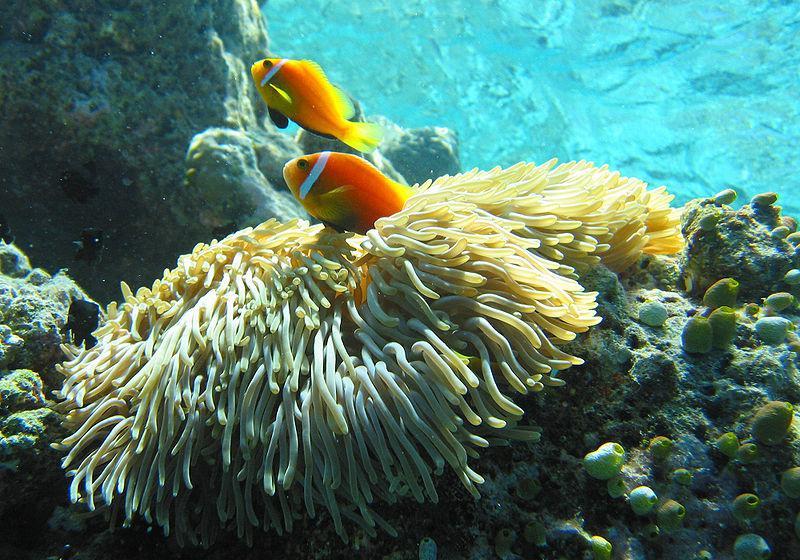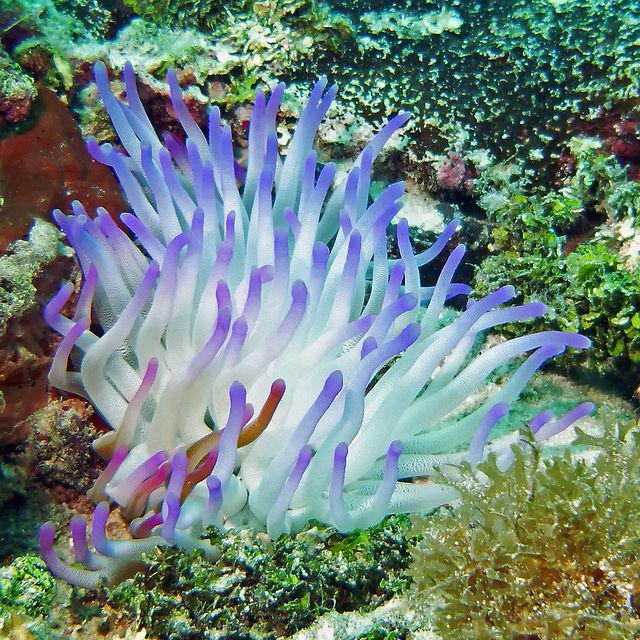The first image is the image on the left, the second image is the image on the right. Given the left and right images, does the statement "No fish are swimming near anemone in at least one image, and in one image the anemone has tendrils that are at least partly purple, while the other image shows neutral-colored anemone." hold true? Answer yes or no. Yes. The first image is the image on the left, the second image is the image on the right. For the images shown, is this caption "The left image has at least one fish with a single stripe near it's head swimming near an anemone" true? Answer yes or no. Yes. 